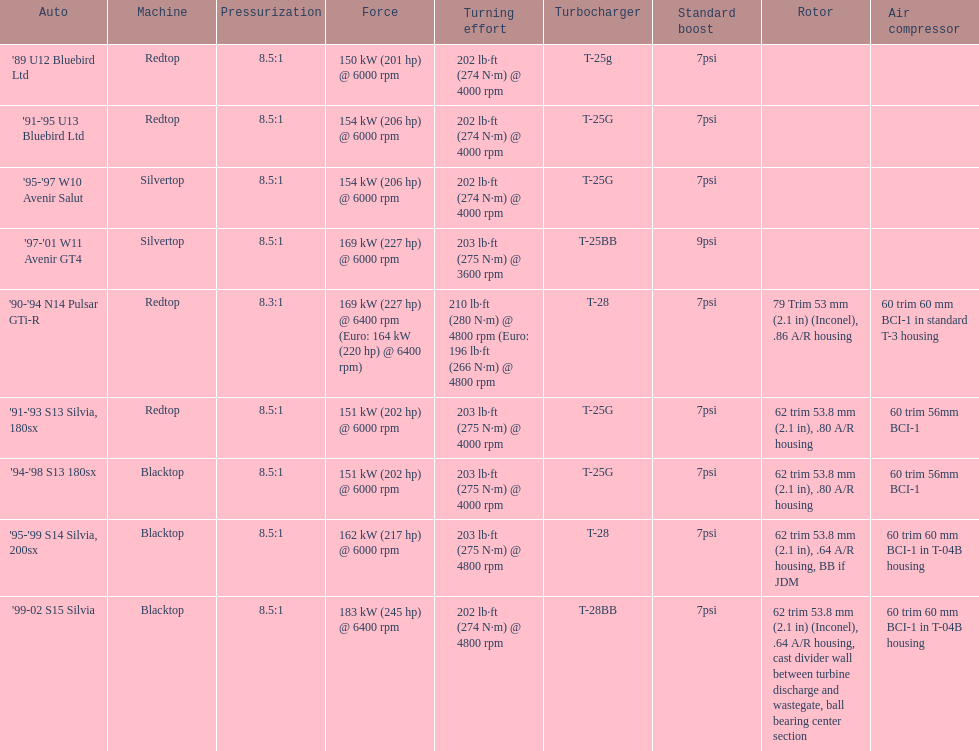Which car is the only one with more than 230 hp? '99-02 S15 Silvia. 